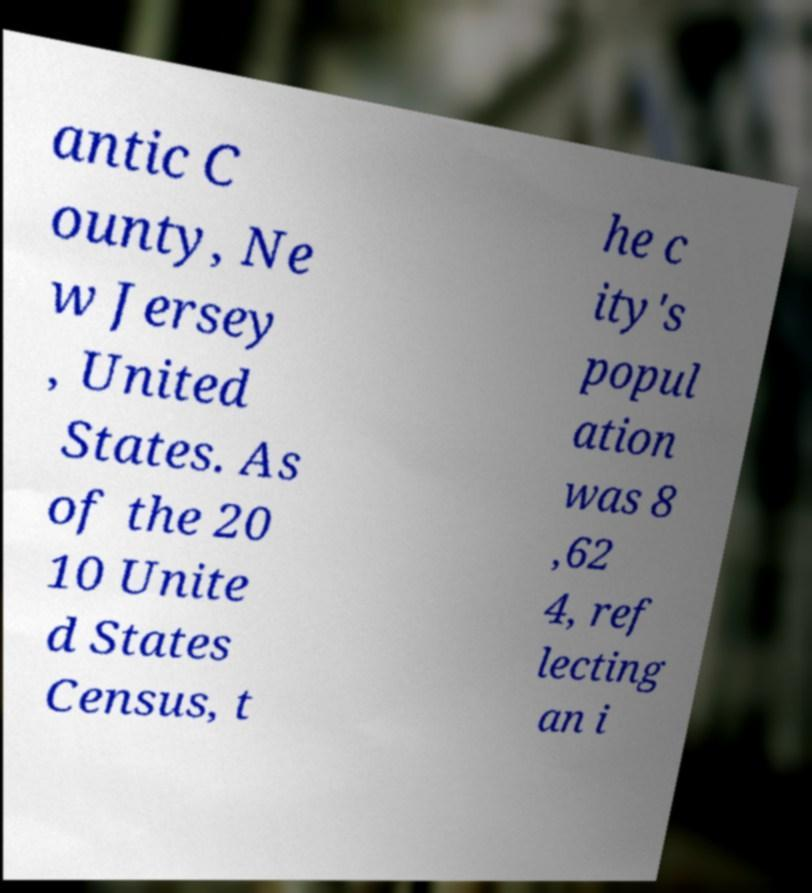Please read and relay the text visible in this image. What does it say? antic C ounty, Ne w Jersey , United States. As of the 20 10 Unite d States Census, t he c ity's popul ation was 8 ,62 4, ref lecting an i 